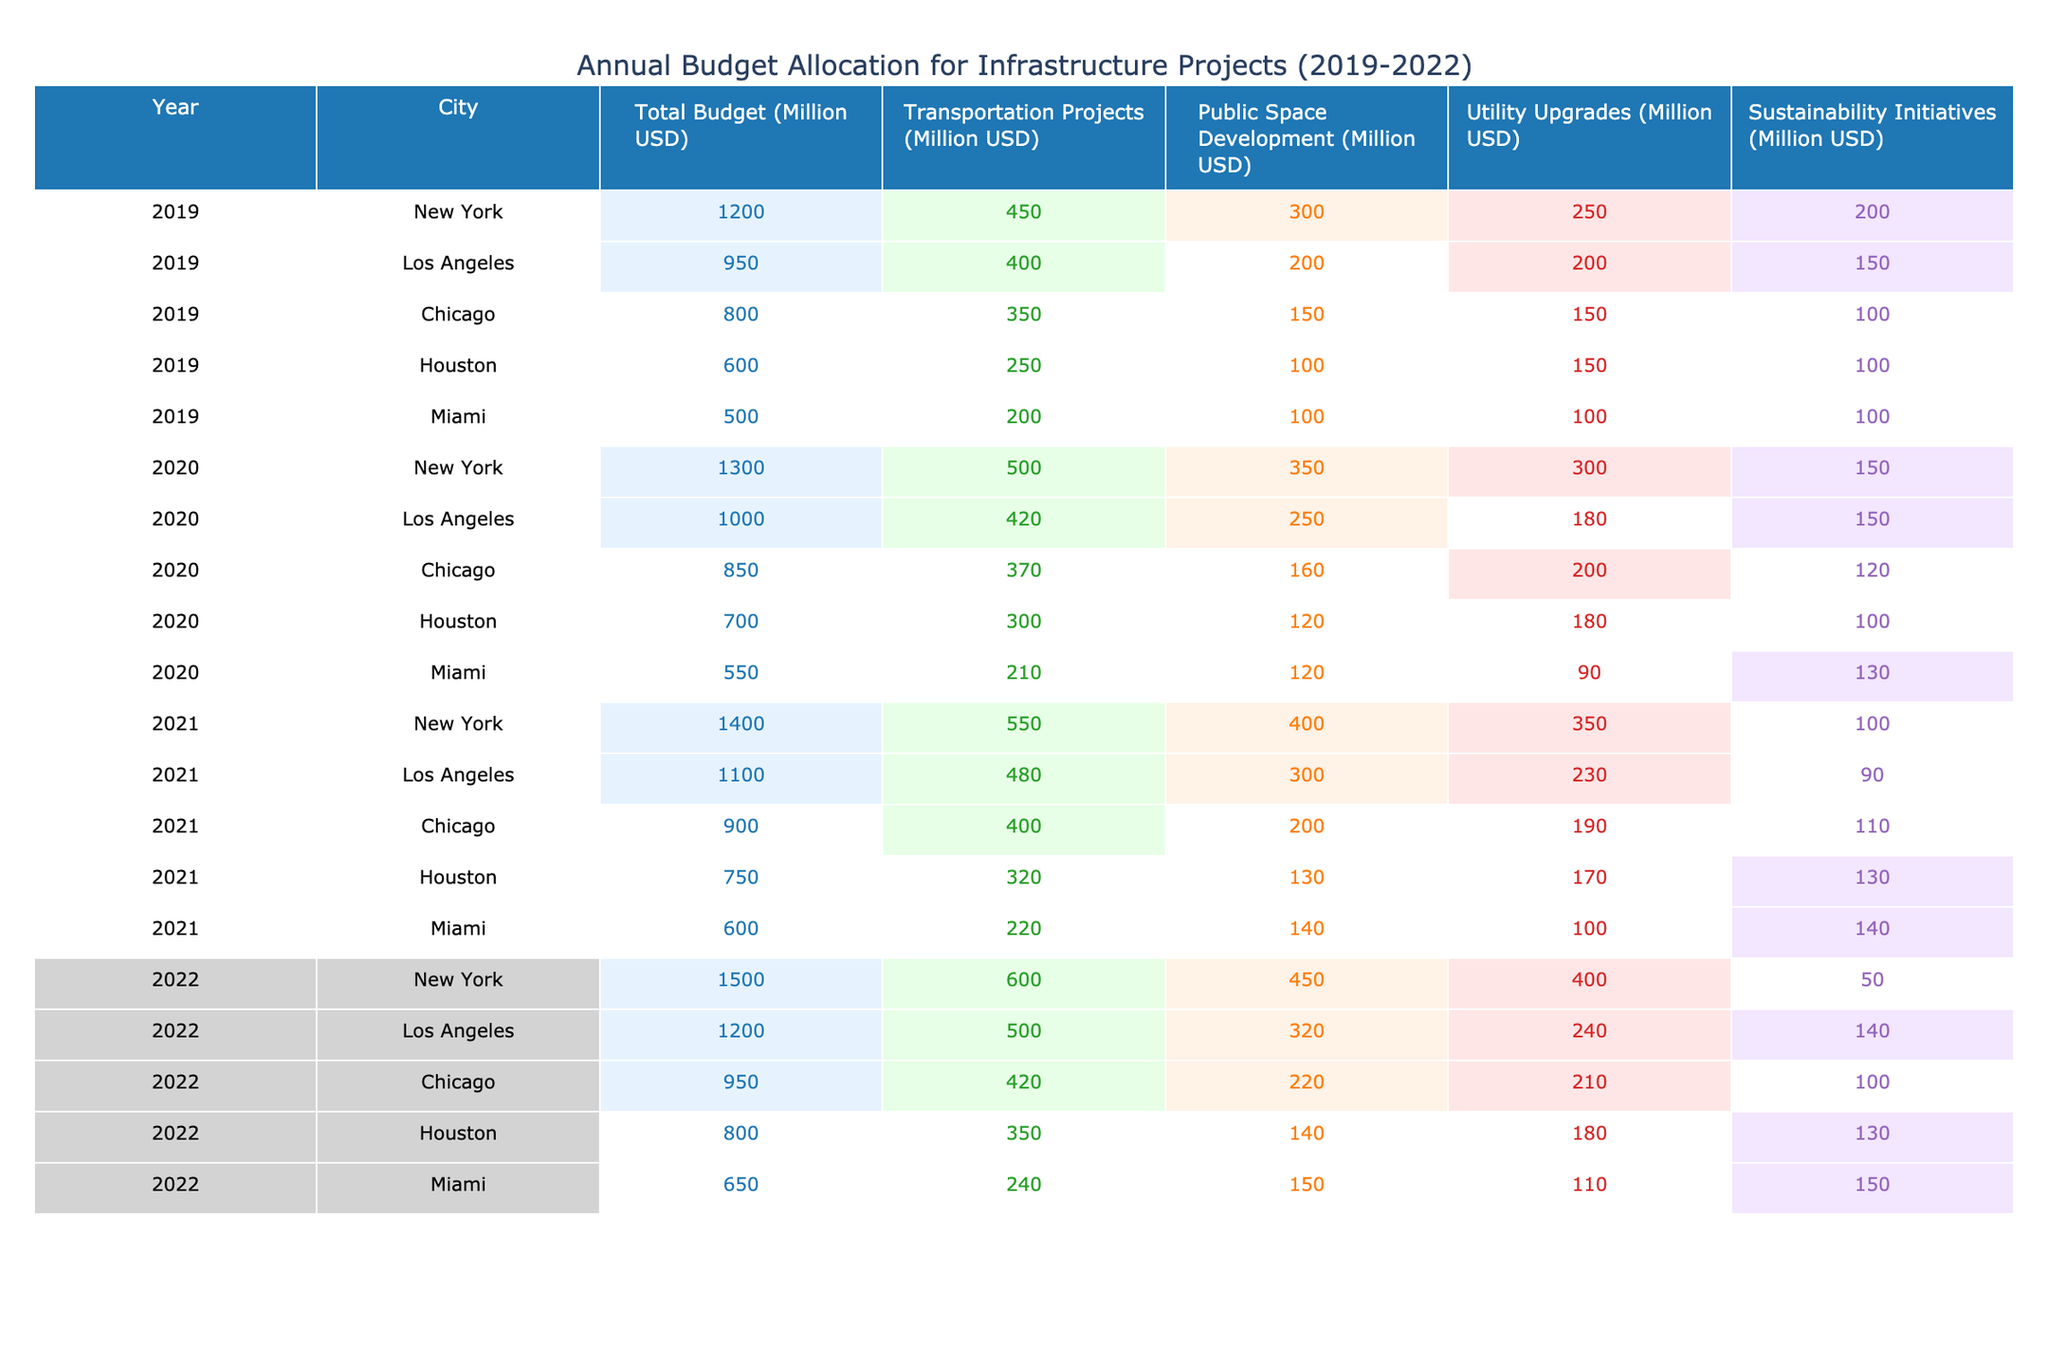What was the total budget for infrastructure projects in New York City in 2020? In the table, find the row for New York City in the year 2020. The total budget listed is 1300 million USD.
Answer: 1300 million USD Which city had the highest allocation for Transportation Projects in 2021? Looking at the 2021 data, New York has 550 million USD for Transportation Projects, which is greater than any of the other cities' allocations for that year.
Answer: New York What is the sum of Public Space Development allocations for all cities in 2019? The allocations for Public Space Development in 2019 are: New York (300), Los Angeles (200), Chicago (150), Houston (100), and Miami (100). Adding these values gives 300 + 200 + 150 + 100 + 100 = 850 million USD.
Answer: 850 million USD Did Miami have a higher total budget in 2022 compared to 2020? The total budget for Miami in 2022 is 650 million USD and in 2020 it is 550 million USD. Since 650 is greater than 550, the statement is true.
Answer: Yes What is the average budget allocation for Utility Upgrades across all cities in 2022? The allocations for Utility Upgrades in 2022 are: New York (400), Los Angeles (240), Chicago (210), Houston (180), and Miami (110). Summing these gives 400 + 240 + 210 + 180 + 110 = 1140 million USD. The average is 1140 divided by 5, which equals 228 million USD.
Answer: 228 million USD Which city had the smallest budget for Sustainability Initiatives in 2020? In 2020, the Sustainability Initiatives budgets are: New York (150), Los Angeles (150), Chicago (120), Houston (100), and Miami (130). The smallest budget is Houston’s 100 million USD.
Answer: Houston Was there a year when Los Angeles' total budget was greater than Chicago's total budget? Connecting the years: In 2020, Los Angeles (1000 million) was greater than Chicago (850 million), and in 2021, Los Angeles (1100 million) was also greater than Chicago (900 million). Therefore, there are two years when this is true.
Answer: Yes How much more did New York allocate to Transportation Projects in 2021 compared to 2020? In 2021, New York allocated 550 million USD to Transportation Projects and in 2020 it was 500 million USD. The difference is 550 - 500 = 50 million USD.
Answer: 50 million USD What trend can you observe in Miami's total budget from 2019 to 2022? Observing the total budgets, Miami's amounts are 500 million in 2019, 550 million in 2020, 600 million in 2021, and 650 million in 2022. This shows a consistent increase each year by 50 million.
Answer: Increasing Which city's total budget allocation showed the largest increase from 2020 to 2021? In 2021, New York had a total budget of 1400 million USD, which is an increase from 1300 million in 2020, making it a 100 million increase. Los Angeles shows an increase of 100 but no other city's increase is larger than New York's increase, based on the figures.
Answer: New York What is the total budget for infrastructure projects across all cities in 2022? The total budgets for each city in 2022 are New York (1500), Los Angeles (1200), Chicago (950), Houston (800), and Miami (650). Adding these amounts gives 1500 + 1200 + 950 + 800 + 650 = 4100 million USD.
Answer: 4100 million USD 